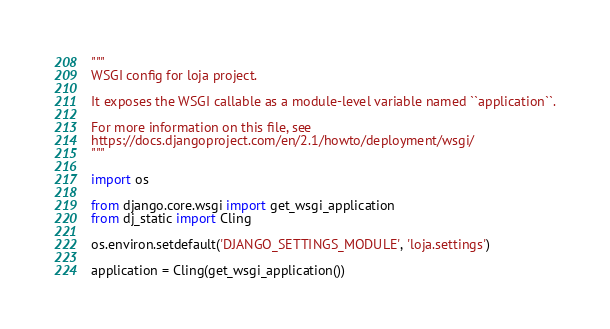Convert code to text. <code><loc_0><loc_0><loc_500><loc_500><_Python_>"""
WSGI config for loja project.

It exposes the WSGI callable as a module-level variable named ``application``.

For more information on this file, see
https://docs.djangoproject.com/en/2.1/howto/deployment/wsgi/
"""

import os

from django.core.wsgi import get_wsgi_application
from dj_static import Cling

os.environ.setdefault('DJANGO_SETTINGS_MODULE', 'loja.settings')

application = Cling(get_wsgi_application())
</code> 